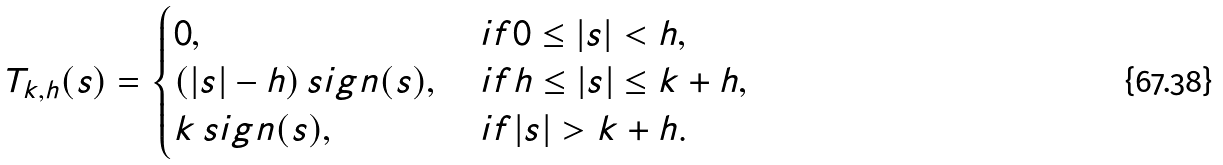<formula> <loc_0><loc_0><loc_500><loc_500>T _ { k , h } ( s ) = \begin{cases} 0 , & \ i f 0 \leq | s | < h , \\ ( | s | - h ) \, s i g n ( s ) , & \ i f h \leq | s | \leq k + h , \\ k \, s i g n ( s ) , & \ i f | s | > k + h . \end{cases}</formula> 